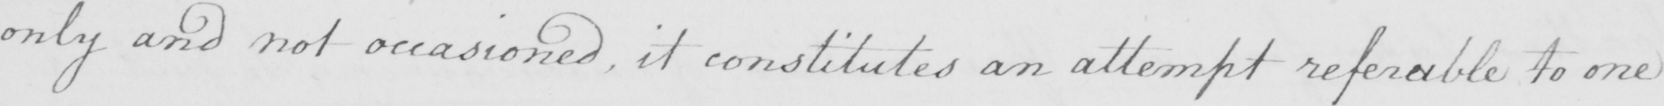Can you tell me what this handwritten text says? only and not occasioned , it constitutes an attempt referable to one 